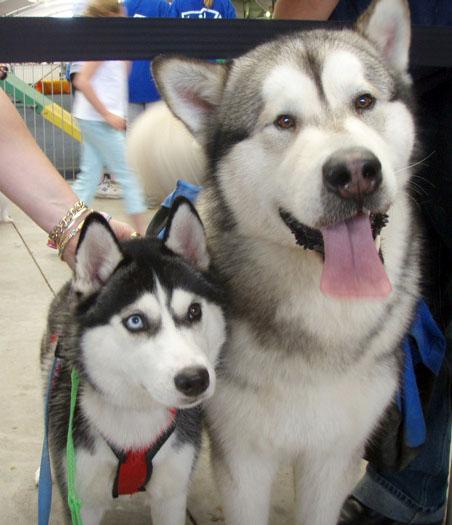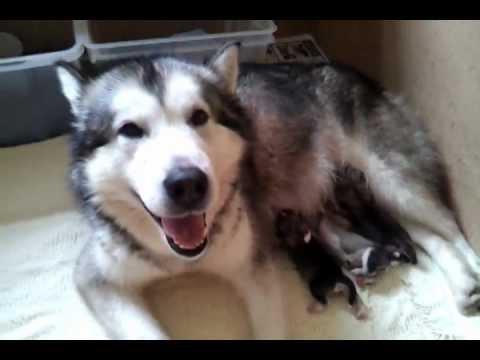The first image is the image on the left, the second image is the image on the right. Considering the images on both sides, is "One image shows a reclining mother dog with her head on the left, nursing multiple puppies with their tails toward the camera." valid? Answer yes or no. Yes. The first image is the image on the left, the second image is the image on the right. For the images shown, is this caption "The left and right image contains the same number of husky puppies." true? Answer yes or no. No. 